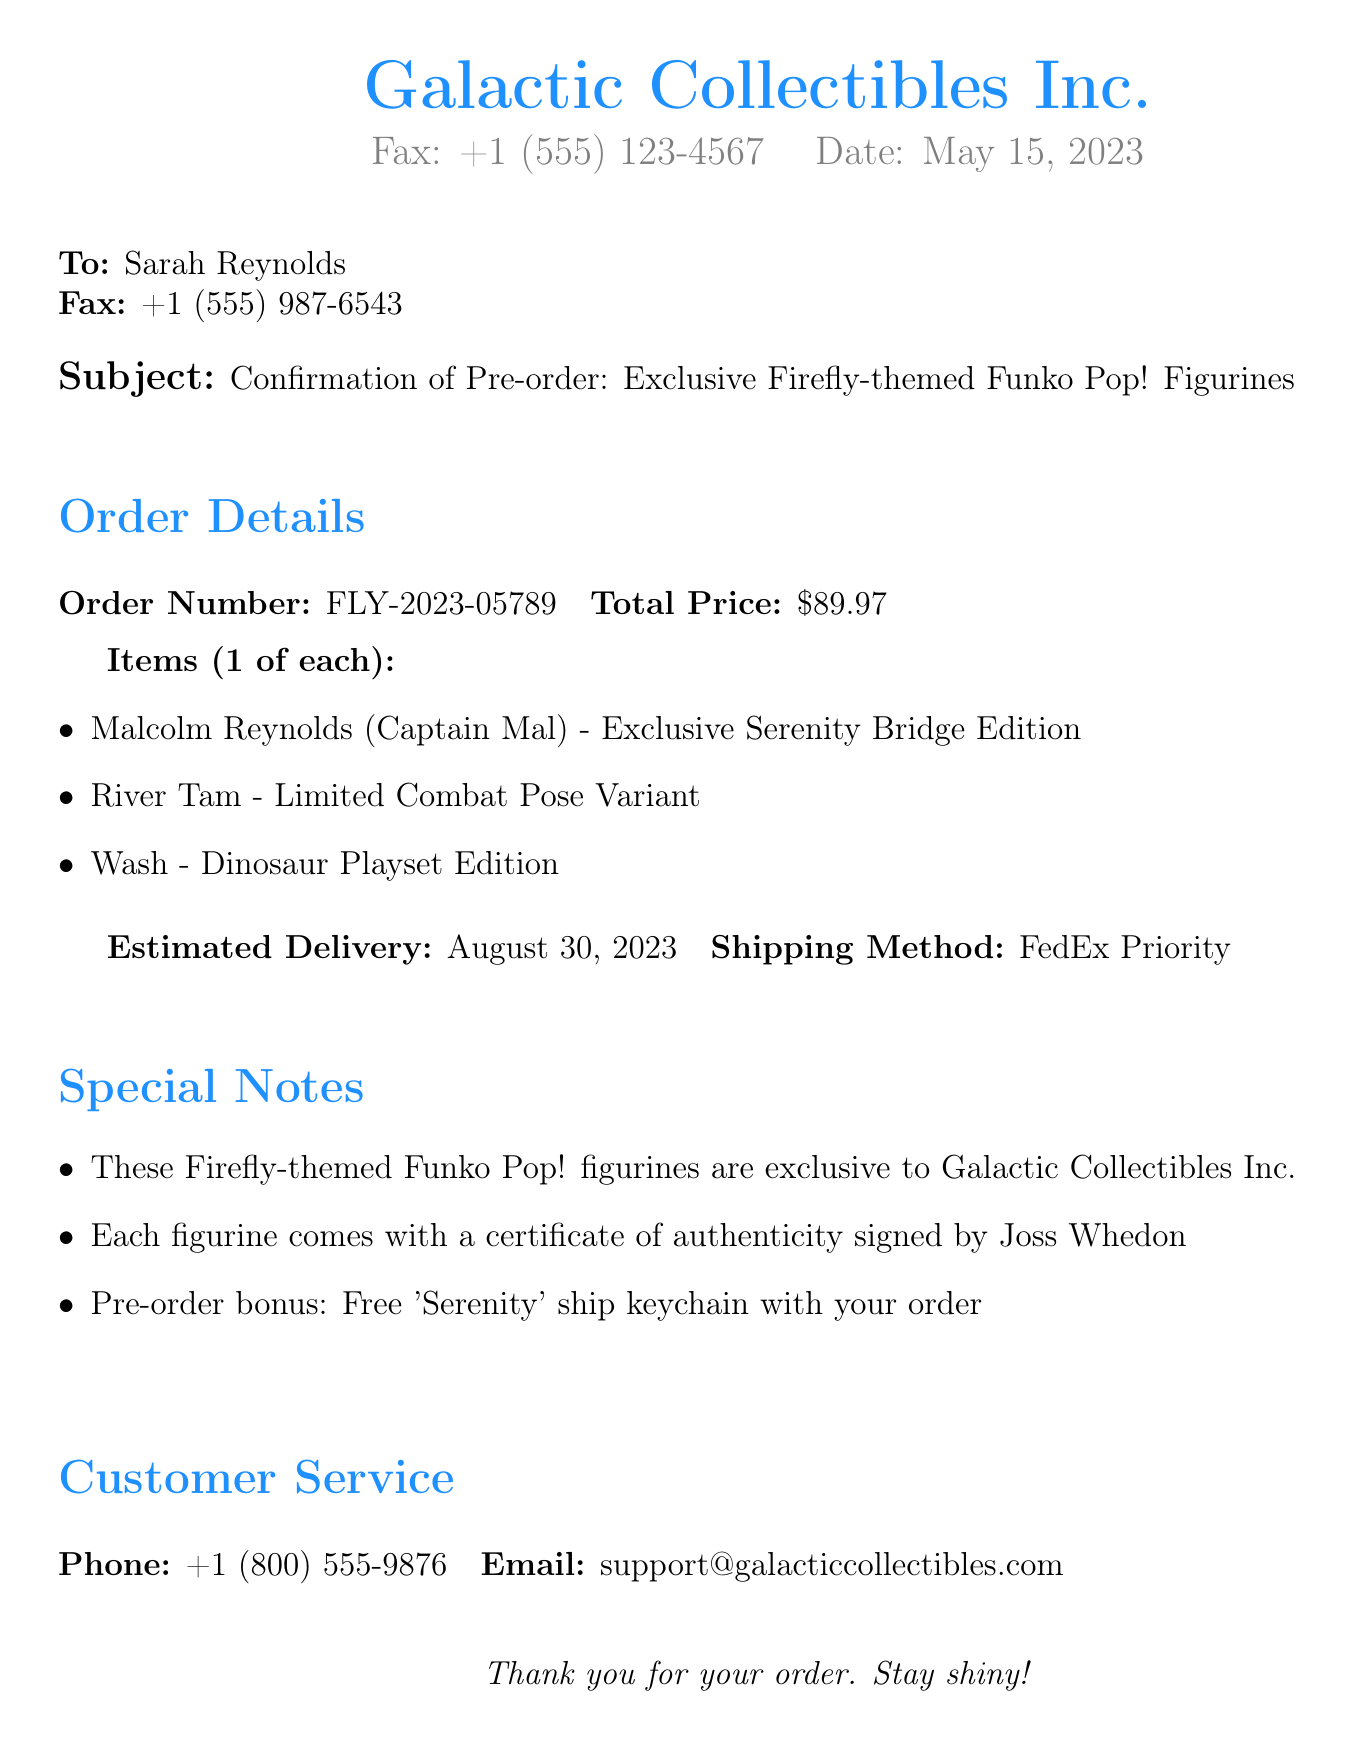What is the order number? The order number is specified in the document as a unique identifier for the pre-order, which is FLY-2023-05789.
Answer: FLY-2023-05789 What items are included in the order? The document lists three exclusive figurines ordered, including Malcolm Reynolds, River Tam, and Wash.
Answer: Malcolm Reynolds, River Tam, Wash What is the total price of the order? The total price is provided in the document as the sum for the order, which is $89.97.
Answer: $89.97 Who is the pre-order bonus from? The pre-order bonus is specified to be a free 'Serenity' ship keychain with the order, which is part of the promotion.
Answer: Free 'Serenity' ship keychain What is the estimated delivery date? The estimated delivery date is clearly stated in the document, which is August 30, 2023.
Answer: August 30, 2023 What shipping method will be used? The shipping method is mentioned in the document as FedEx Priority for the delivery of the order.
Answer: FedEx Priority Who can customers contact for support? Customer service contact details are specified in the document, including a phone number and email for support.
Answer: +1 (800) 555-9876 What certificate comes with the figurines? Each figurine comes with a certificate of authenticity signed by Joss Whedon, which adds value to the exclusivity.
Answer: Certificate of authenticity signed by Joss Whedon How many items were pre-ordered? The document mentions that one of each exclusive Firefly-themed Funko Pop! figurine was ordered, indicating the quantity is three.
Answer: 3 